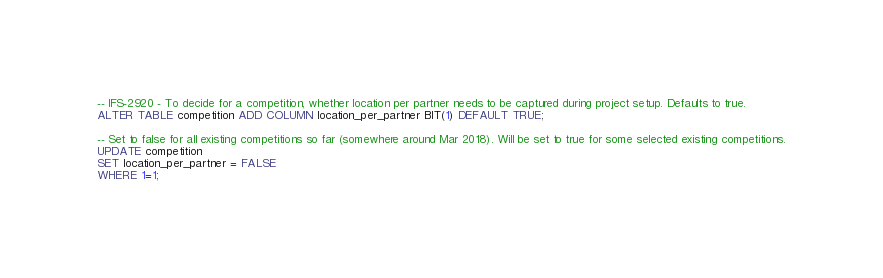<code> <loc_0><loc_0><loc_500><loc_500><_SQL_>-- IFS-2920 - To decide for a competition, whether location per partner needs to be captured during project setup. Defaults to true.
ALTER TABLE competition ADD COLUMN location_per_partner BIT(1) DEFAULT TRUE;

-- Set to false for all existing competitions so far (somewhere around Mar 2018). Will be set to true for some selected existing competitions.
UPDATE competition
SET location_per_partner = FALSE
WHERE 1=1;</code> 